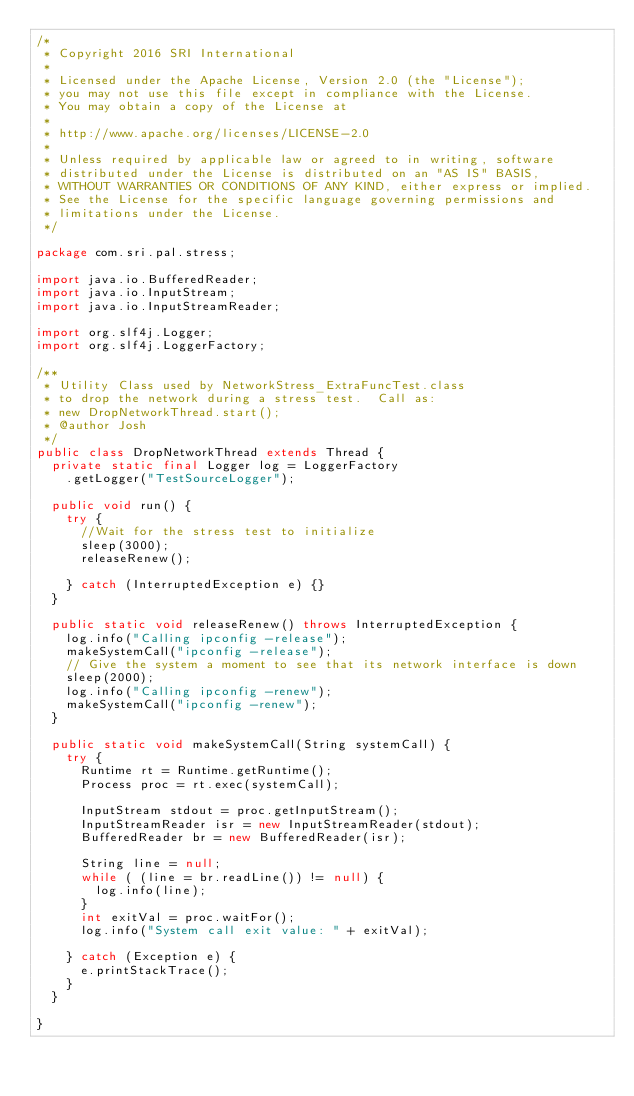<code> <loc_0><loc_0><loc_500><loc_500><_Java_>/*
 * Copyright 2016 SRI International
 *
 * Licensed under the Apache License, Version 2.0 (the "License");
 * you may not use this file except in compliance with the License.
 * You may obtain a copy of the License at
 *
 * http://www.apache.org/licenses/LICENSE-2.0
 *
 * Unless required by applicable law or agreed to in writing, software
 * distributed under the License is distributed on an "AS IS" BASIS,
 * WITHOUT WARRANTIES OR CONDITIONS OF ANY KIND, either express or implied.
 * See the License for the specific language governing permissions and
 * limitations under the License.
 */

package com.sri.pal.stress;

import java.io.BufferedReader;
import java.io.InputStream;
import java.io.InputStreamReader;

import org.slf4j.Logger;
import org.slf4j.LoggerFactory;

/**
 * Utility Class used by NetworkStress_ExtraFuncTest.class
 * to drop the network during a stress test.  Call as:
 * new DropNetworkThread.start();
 * @author Josh
 */
public class DropNetworkThread extends Thread {
	private static final Logger log = LoggerFactory
    .getLogger("TestSourceLogger");

	public void run() {
		try {
			//Wait for the stress test to initialize
			sleep(3000);
			releaseRenew();

		} catch (InterruptedException e) {}
	}

	public static void releaseRenew() throws InterruptedException {
		log.info("Calling ipconfig -release");
		makeSystemCall("ipconfig -release");
		// Give the system a moment to see that its network interface is down
		sleep(2000);
		log.info("Calling ipconfig -renew");
		makeSystemCall("ipconfig -renew");
	}

	public static void makeSystemCall(String systemCall) {
		try {
			Runtime rt = Runtime.getRuntime();
			Process proc = rt.exec(systemCall);

			InputStream stdout = proc.getInputStream();
			InputStreamReader isr = new InputStreamReader(stdout);
			BufferedReader br = new BufferedReader(isr);

			String line = null;
			while ( (line = br.readLine()) != null) {
				log.info(line);
			}
			int exitVal = proc.waitFor();
			log.info("System call exit value: " + exitVal);

		} catch (Exception e) {
			e.printStackTrace();
		}
	}

}</code> 